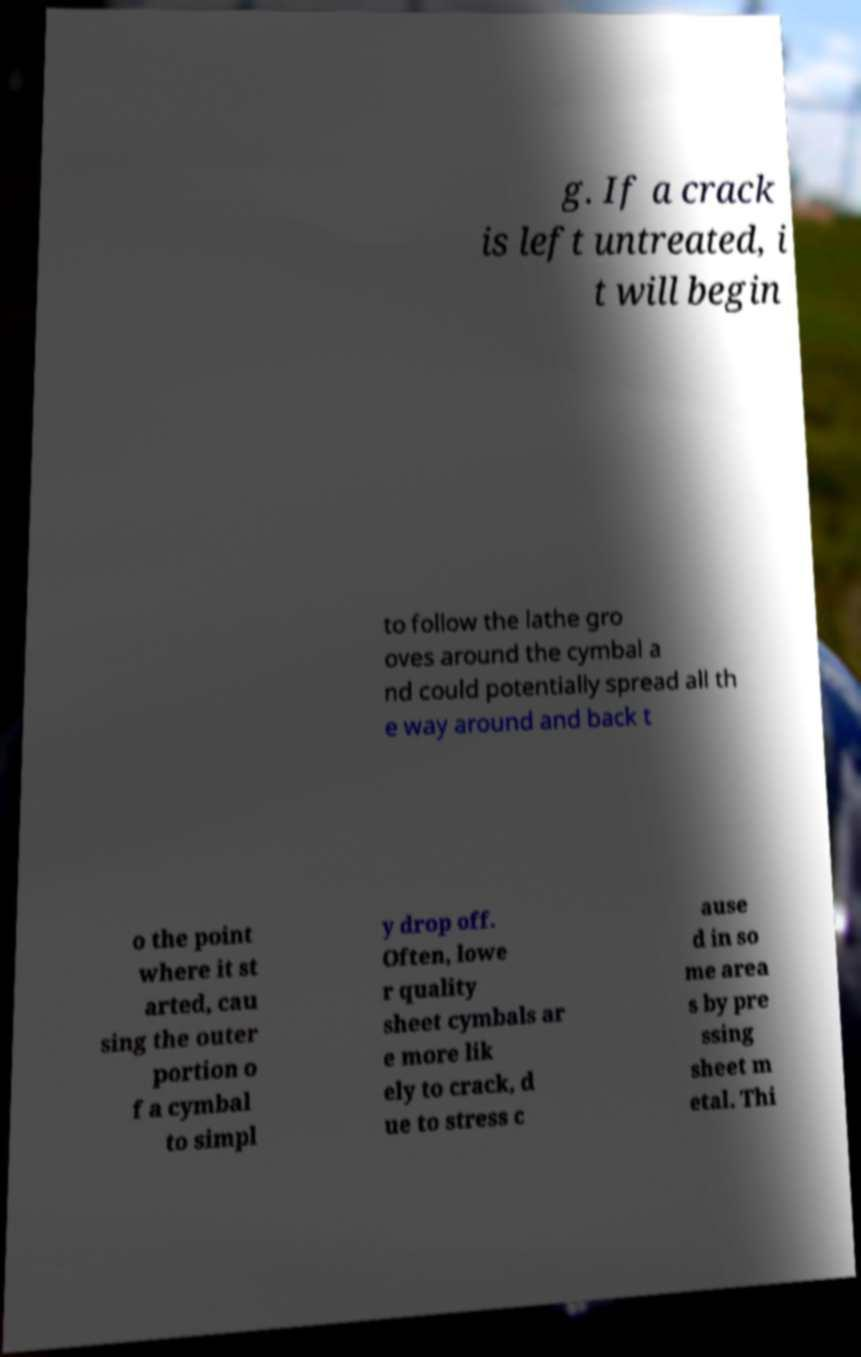Please identify and transcribe the text found in this image. g. If a crack is left untreated, i t will begin to follow the lathe gro oves around the cymbal a nd could potentially spread all th e way around and back t o the point where it st arted, cau sing the outer portion o f a cymbal to simpl y drop off. Often, lowe r quality sheet cymbals ar e more lik ely to crack, d ue to stress c ause d in so me area s by pre ssing sheet m etal. Thi 